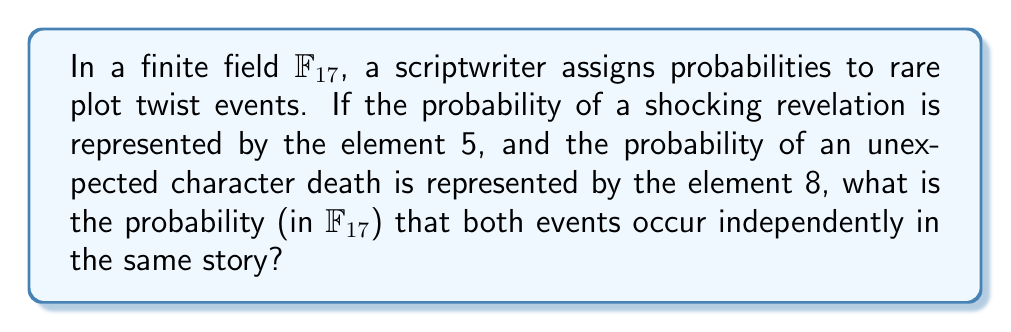Help me with this question. To solve this problem, we'll follow these steps:

1) In finite field arithmetic, probabilities are represented by field elements. The probability of independent events occurring together is calculated by multiplying their individual probabilities.

2) In this case, we need to multiply 5 and 8 in $\mathbb{F}_{17}$.

3) In $\mathbb{F}_{17}$, arithmetic is performed modulo 17. So:

   $5 \times 8 = 40 \equiv 6 \pmod{17}$

4) We can verify this:
   $40 = 2 \times 17 + 6$

5) Therefore, in $\mathbb{F}_{17}$, $5 \times 8 = 6$

This means that the probability of both rare events occurring in the same story is represented by the element 6 in $\mathbb{F}_{17}$.

Note: In finite field probability theory, the usual interpretation of probabilities as real numbers between 0 and 1 doesn't apply. Instead, field elements represent abstract probabilities, maintaining the algebraic structure of probability theory.
Answer: 6 